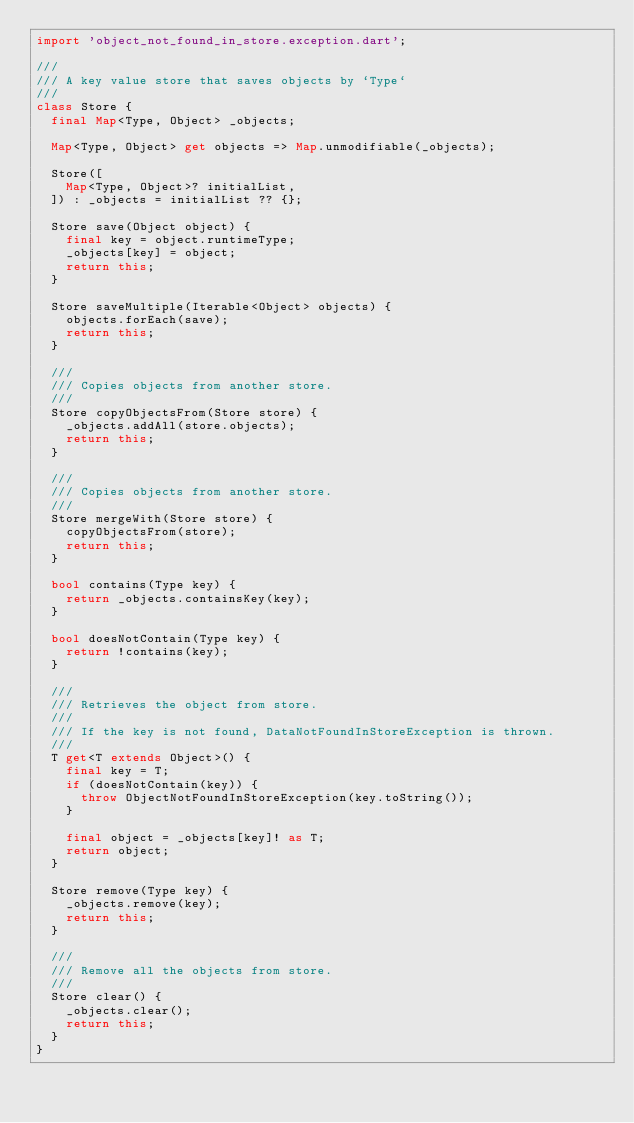Convert code to text. <code><loc_0><loc_0><loc_500><loc_500><_Dart_>import 'object_not_found_in_store.exception.dart';

///
/// A key value store that saves objects by `Type`
///
class Store {
  final Map<Type, Object> _objects;

  Map<Type, Object> get objects => Map.unmodifiable(_objects);

  Store([
    Map<Type, Object>? initialList,
  ]) : _objects = initialList ?? {};

  Store save(Object object) {
    final key = object.runtimeType;
    _objects[key] = object;
    return this;
  }

  Store saveMultiple(Iterable<Object> objects) {
    objects.forEach(save);
    return this;
  }

  ///
  /// Copies objects from another store.
  ///
  Store copyObjectsFrom(Store store) {
    _objects.addAll(store.objects);
    return this;
  }

  ///
  /// Copies objects from another store.
  ///
  Store mergeWith(Store store) {
    copyObjectsFrom(store);
    return this;
  }

  bool contains(Type key) {
    return _objects.containsKey(key);
  }

  bool doesNotContain(Type key) {
    return !contains(key);
  }

  ///
  /// Retrieves the object from store.
  ///
  /// If the key is not found, DataNotFoundInStoreException is thrown.
  ///
  T get<T extends Object>() {
    final key = T;
    if (doesNotContain(key)) {
      throw ObjectNotFoundInStoreException(key.toString());
    }

    final object = _objects[key]! as T;
    return object;
  }

  Store remove(Type key) {
    _objects.remove(key);
    return this;
  }

  ///
  /// Remove all the objects from store.
  ///
  Store clear() {
    _objects.clear();
    return this;
  }
}
</code> 